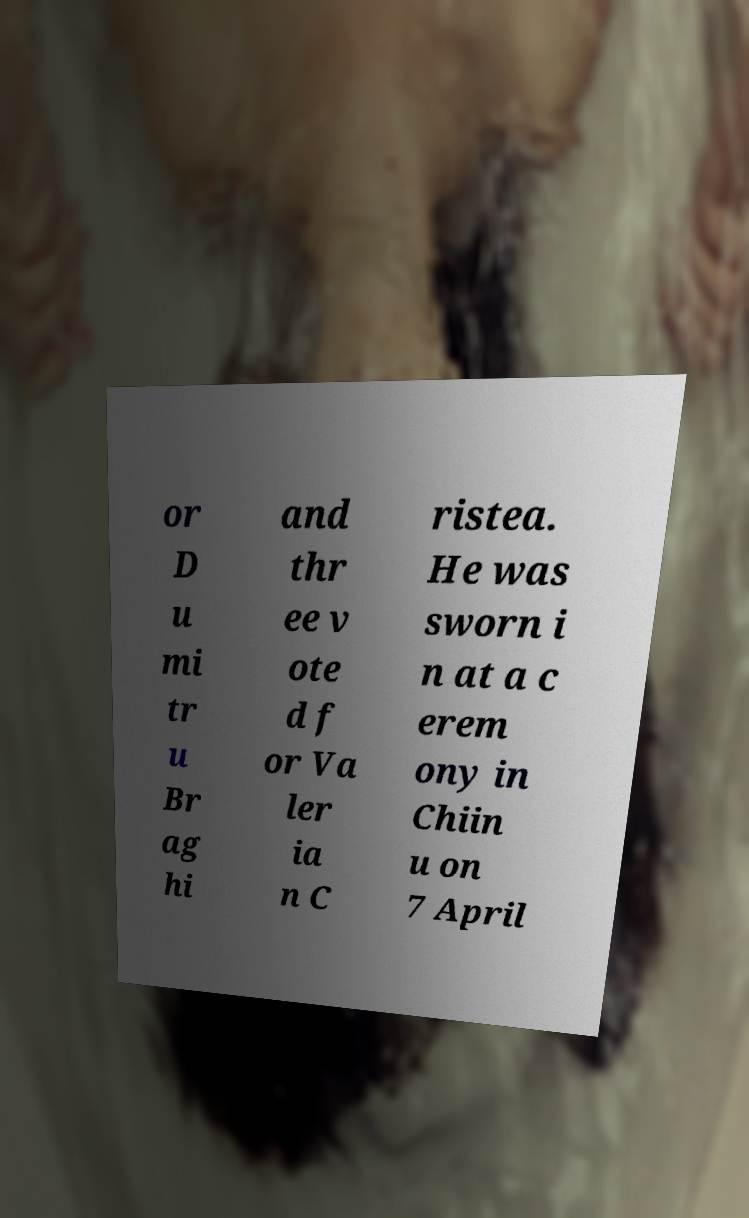Can you accurately transcribe the text from the provided image for me? or D u mi tr u Br ag hi and thr ee v ote d f or Va ler ia n C ristea. He was sworn i n at a c erem ony in Chiin u on 7 April 